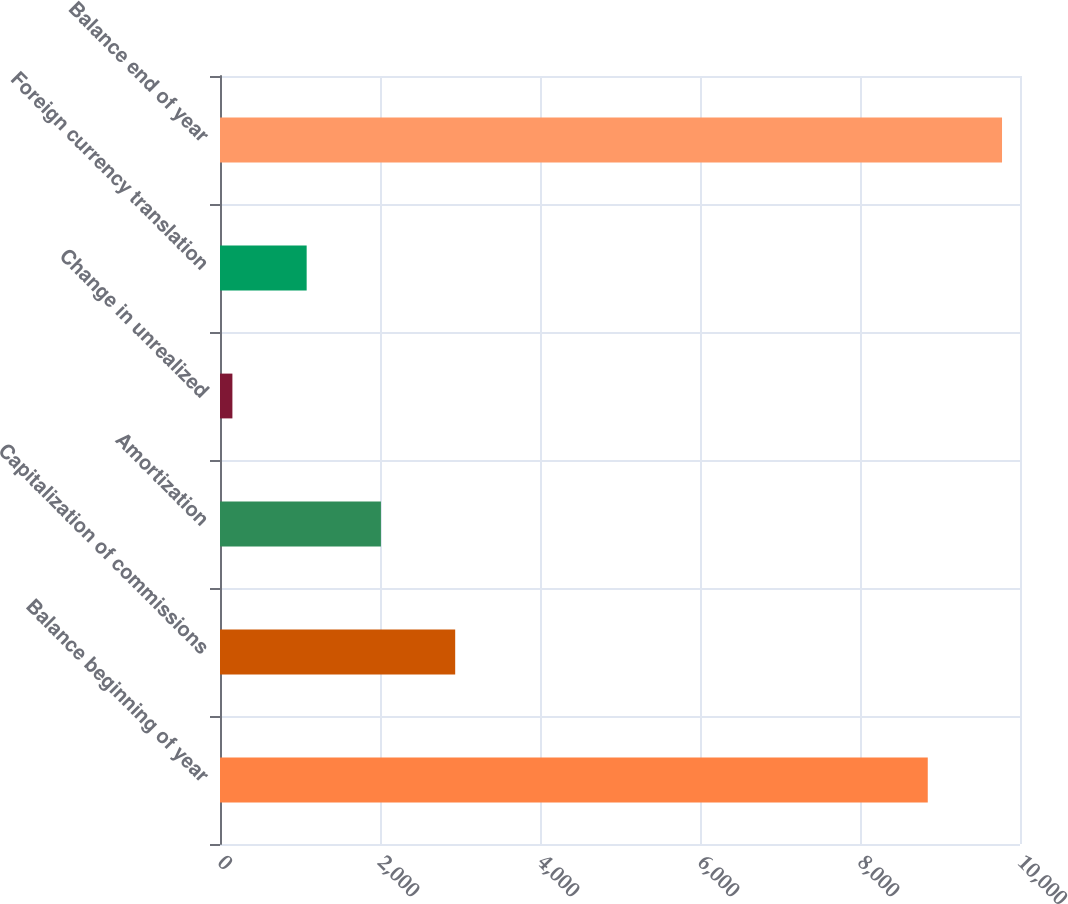Convert chart. <chart><loc_0><loc_0><loc_500><loc_500><bar_chart><fcel>Balance beginning of year<fcel>Capitalization of commissions<fcel>Amortization<fcel>Change in unrealized<fcel>Foreign currency translation<fcel>Balance end of year<nl><fcel>8847<fcel>2939.9<fcel>2011.6<fcel>155<fcel>1083.3<fcel>9775.3<nl></chart> 